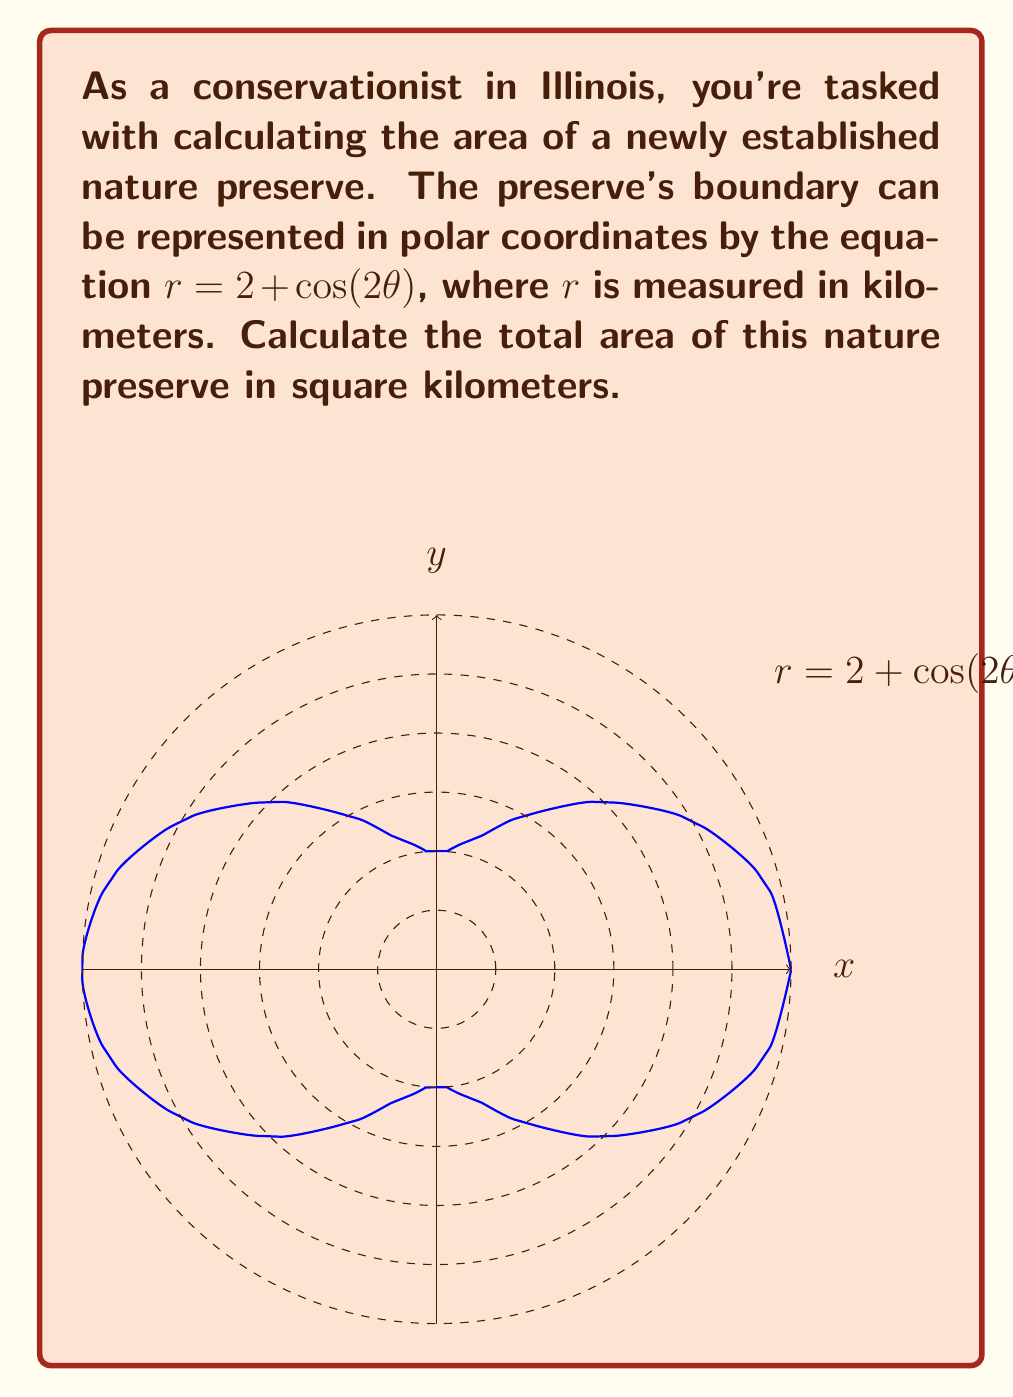Could you help me with this problem? To calculate the area enclosed by a polar curve, we use the formula:

$$A = \frac{1}{2} \int_{0}^{2\pi} r^2(\theta) d\theta$$

For our curve, $r(\theta) = 2 + \cos(2\theta)$. Let's follow these steps:

1) Square the radius function:
   $$r^2(\theta) = (2 + \cos(2\theta))^2 = 4 + 4\cos(2\theta) + \cos^2(2\theta)$$

2) Expand using the identity $\cos^2(x) = \frac{1}{2}(1 + \cos(2x))$:
   $$r^2(\theta) = 4 + 4\cos(2\theta) + \frac{1}{2}(1 + \cos(4\theta)) = \frac{9}{2} + 4\cos(2\theta) + \frac{1}{2}\cos(4\theta)$$

3) Now, set up the integral:
   $$A = \frac{1}{2} \int_{0}^{2\pi} (\frac{9}{2} + 4\cos(2\theta) + \frac{1}{2}\cos(4\theta)) d\theta$$

4) Integrate term by term:
   $$A = \frac{1}{2} [\frac{9}{2}\theta + 2\sin(2\theta) + \frac{1}{8}\sin(4\theta)]_{0}^{2\pi}$$

5) Evaluate the definite integral:
   $$A = \frac{1}{2} [(\frac{9}{2} \cdot 2\pi + 0 + 0) - (0 + 0 + 0)] = \frac{9\pi}{2}$$

Therefore, the area of the nature preserve is $\frac{9\pi}{2}$ square kilometers.
Answer: $\frac{9\pi}{2}$ sq km 